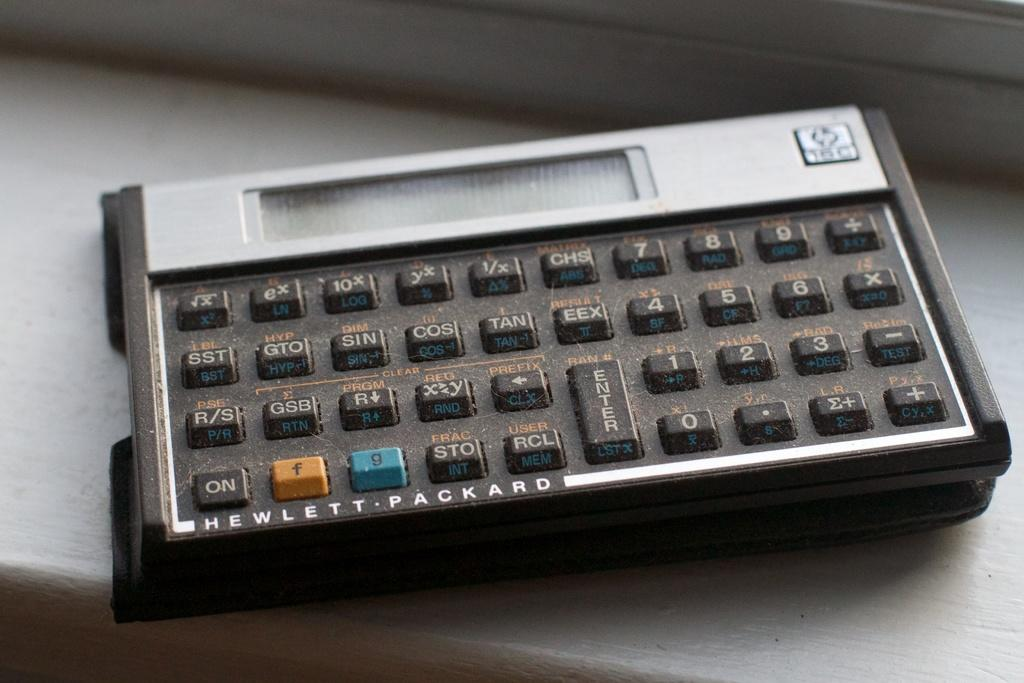<image>
Give a short and clear explanation of the subsequent image. A Hewlett Packard calculator has a number pad as well as numerous function buttons. 